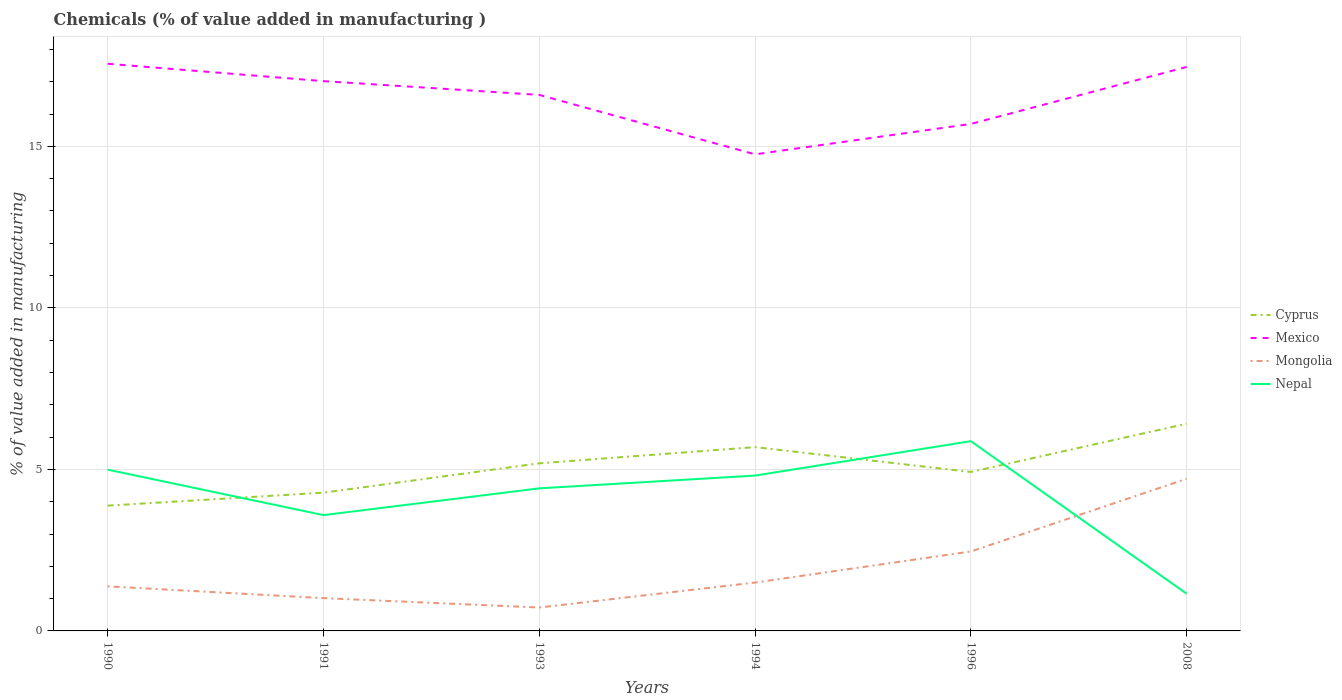How many different coloured lines are there?
Your response must be concise. 4. Does the line corresponding to Mongolia intersect with the line corresponding to Cyprus?
Provide a short and direct response. No. Across all years, what is the maximum value added in manufacturing chemicals in Nepal?
Ensure brevity in your answer.  1.15. What is the total value added in manufacturing chemicals in Mongolia in the graph?
Your response must be concise. -1.44. What is the difference between the highest and the second highest value added in manufacturing chemicals in Cyprus?
Offer a very short reply. 2.54. How many lines are there?
Offer a very short reply. 4. How many years are there in the graph?
Ensure brevity in your answer.  6. Are the values on the major ticks of Y-axis written in scientific E-notation?
Your answer should be very brief. No. Does the graph contain grids?
Your answer should be compact. Yes. How are the legend labels stacked?
Your answer should be very brief. Vertical. What is the title of the graph?
Offer a terse response. Chemicals (% of value added in manufacturing ). Does "Sao Tome and Principe" appear as one of the legend labels in the graph?
Provide a short and direct response. No. What is the label or title of the X-axis?
Make the answer very short. Years. What is the label or title of the Y-axis?
Offer a terse response. % of value added in manufacturing. What is the % of value added in manufacturing of Cyprus in 1990?
Ensure brevity in your answer.  3.88. What is the % of value added in manufacturing of Mexico in 1990?
Ensure brevity in your answer.  17.56. What is the % of value added in manufacturing of Mongolia in 1990?
Offer a terse response. 1.38. What is the % of value added in manufacturing of Nepal in 1990?
Ensure brevity in your answer.  4.99. What is the % of value added in manufacturing of Cyprus in 1991?
Offer a very short reply. 4.28. What is the % of value added in manufacturing of Mexico in 1991?
Give a very brief answer. 17.02. What is the % of value added in manufacturing in Mongolia in 1991?
Provide a succinct answer. 1.02. What is the % of value added in manufacturing of Nepal in 1991?
Your answer should be compact. 3.58. What is the % of value added in manufacturing of Cyprus in 1993?
Offer a terse response. 5.19. What is the % of value added in manufacturing of Mexico in 1993?
Provide a succinct answer. 16.59. What is the % of value added in manufacturing of Mongolia in 1993?
Ensure brevity in your answer.  0.72. What is the % of value added in manufacturing of Nepal in 1993?
Provide a succinct answer. 4.41. What is the % of value added in manufacturing of Cyprus in 1994?
Provide a short and direct response. 5.69. What is the % of value added in manufacturing of Mexico in 1994?
Provide a succinct answer. 14.75. What is the % of value added in manufacturing of Mongolia in 1994?
Ensure brevity in your answer.  1.5. What is the % of value added in manufacturing in Nepal in 1994?
Your response must be concise. 4.81. What is the % of value added in manufacturing in Cyprus in 1996?
Offer a very short reply. 4.92. What is the % of value added in manufacturing in Mexico in 1996?
Provide a succinct answer. 15.69. What is the % of value added in manufacturing of Mongolia in 1996?
Offer a terse response. 2.46. What is the % of value added in manufacturing in Nepal in 1996?
Provide a short and direct response. 5.87. What is the % of value added in manufacturing in Cyprus in 2008?
Your answer should be compact. 6.41. What is the % of value added in manufacturing in Mexico in 2008?
Your answer should be compact. 17.46. What is the % of value added in manufacturing of Mongolia in 2008?
Provide a short and direct response. 4.71. What is the % of value added in manufacturing in Nepal in 2008?
Keep it short and to the point. 1.15. Across all years, what is the maximum % of value added in manufacturing of Cyprus?
Offer a very short reply. 6.41. Across all years, what is the maximum % of value added in manufacturing in Mexico?
Keep it short and to the point. 17.56. Across all years, what is the maximum % of value added in manufacturing in Mongolia?
Offer a very short reply. 4.71. Across all years, what is the maximum % of value added in manufacturing of Nepal?
Ensure brevity in your answer.  5.87. Across all years, what is the minimum % of value added in manufacturing in Cyprus?
Ensure brevity in your answer.  3.88. Across all years, what is the minimum % of value added in manufacturing in Mexico?
Offer a very short reply. 14.75. Across all years, what is the minimum % of value added in manufacturing of Mongolia?
Ensure brevity in your answer.  0.72. Across all years, what is the minimum % of value added in manufacturing of Nepal?
Make the answer very short. 1.15. What is the total % of value added in manufacturing of Cyprus in the graph?
Your answer should be very brief. 30.37. What is the total % of value added in manufacturing of Mexico in the graph?
Your response must be concise. 99.07. What is the total % of value added in manufacturing in Mongolia in the graph?
Provide a succinct answer. 11.78. What is the total % of value added in manufacturing in Nepal in the graph?
Keep it short and to the point. 24.82. What is the difference between the % of value added in manufacturing in Cyprus in 1990 and that in 1991?
Offer a very short reply. -0.4. What is the difference between the % of value added in manufacturing in Mexico in 1990 and that in 1991?
Make the answer very short. 0.54. What is the difference between the % of value added in manufacturing in Mongolia in 1990 and that in 1991?
Make the answer very short. 0.36. What is the difference between the % of value added in manufacturing of Nepal in 1990 and that in 1991?
Keep it short and to the point. 1.41. What is the difference between the % of value added in manufacturing of Cyprus in 1990 and that in 1993?
Offer a terse response. -1.31. What is the difference between the % of value added in manufacturing of Mexico in 1990 and that in 1993?
Your answer should be very brief. 0.96. What is the difference between the % of value added in manufacturing in Mongolia in 1990 and that in 1993?
Ensure brevity in your answer.  0.66. What is the difference between the % of value added in manufacturing in Nepal in 1990 and that in 1993?
Give a very brief answer. 0.58. What is the difference between the % of value added in manufacturing of Cyprus in 1990 and that in 1994?
Your answer should be compact. -1.81. What is the difference between the % of value added in manufacturing of Mexico in 1990 and that in 1994?
Your answer should be very brief. 2.8. What is the difference between the % of value added in manufacturing in Mongolia in 1990 and that in 1994?
Offer a very short reply. -0.12. What is the difference between the % of value added in manufacturing in Nepal in 1990 and that in 1994?
Ensure brevity in your answer.  0.18. What is the difference between the % of value added in manufacturing in Cyprus in 1990 and that in 1996?
Your answer should be very brief. -1.04. What is the difference between the % of value added in manufacturing in Mexico in 1990 and that in 1996?
Keep it short and to the point. 1.86. What is the difference between the % of value added in manufacturing in Mongolia in 1990 and that in 1996?
Ensure brevity in your answer.  -1.08. What is the difference between the % of value added in manufacturing in Nepal in 1990 and that in 1996?
Keep it short and to the point. -0.88. What is the difference between the % of value added in manufacturing in Cyprus in 1990 and that in 2008?
Your answer should be compact. -2.54. What is the difference between the % of value added in manufacturing of Mexico in 1990 and that in 2008?
Your response must be concise. 0.1. What is the difference between the % of value added in manufacturing in Mongolia in 1990 and that in 2008?
Your answer should be compact. -3.33. What is the difference between the % of value added in manufacturing in Nepal in 1990 and that in 2008?
Your answer should be very brief. 3.84. What is the difference between the % of value added in manufacturing of Cyprus in 1991 and that in 1993?
Provide a short and direct response. -0.91. What is the difference between the % of value added in manufacturing of Mexico in 1991 and that in 1993?
Your response must be concise. 0.43. What is the difference between the % of value added in manufacturing of Mongolia in 1991 and that in 1993?
Make the answer very short. 0.29. What is the difference between the % of value added in manufacturing of Nepal in 1991 and that in 1993?
Offer a very short reply. -0.83. What is the difference between the % of value added in manufacturing in Cyprus in 1991 and that in 1994?
Keep it short and to the point. -1.41. What is the difference between the % of value added in manufacturing of Mexico in 1991 and that in 1994?
Offer a terse response. 2.27. What is the difference between the % of value added in manufacturing in Mongolia in 1991 and that in 1994?
Ensure brevity in your answer.  -0.48. What is the difference between the % of value added in manufacturing in Nepal in 1991 and that in 1994?
Offer a very short reply. -1.22. What is the difference between the % of value added in manufacturing of Cyprus in 1991 and that in 1996?
Your answer should be very brief. -0.64. What is the difference between the % of value added in manufacturing of Mexico in 1991 and that in 1996?
Provide a short and direct response. 1.32. What is the difference between the % of value added in manufacturing in Mongolia in 1991 and that in 1996?
Ensure brevity in your answer.  -1.44. What is the difference between the % of value added in manufacturing in Nepal in 1991 and that in 1996?
Make the answer very short. -2.29. What is the difference between the % of value added in manufacturing in Cyprus in 1991 and that in 2008?
Offer a terse response. -2.13. What is the difference between the % of value added in manufacturing in Mexico in 1991 and that in 2008?
Give a very brief answer. -0.44. What is the difference between the % of value added in manufacturing of Mongolia in 1991 and that in 2008?
Your answer should be compact. -3.69. What is the difference between the % of value added in manufacturing of Nepal in 1991 and that in 2008?
Offer a terse response. 2.43. What is the difference between the % of value added in manufacturing of Cyprus in 1993 and that in 1994?
Offer a very short reply. -0.5. What is the difference between the % of value added in manufacturing of Mexico in 1993 and that in 1994?
Your answer should be very brief. 1.84. What is the difference between the % of value added in manufacturing in Mongolia in 1993 and that in 1994?
Give a very brief answer. -0.77. What is the difference between the % of value added in manufacturing in Nepal in 1993 and that in 1994?
Give a very brief answer. -0.4. What is the difference between the % of value added in manufacturing of Cyprus in 1993 and that in 1996?
Ensure brevity in your answer.  0.27. What is the difference between the % of value added in manufacturing of Mexico in 1993 and that in 1996?
Provide a short and direct response. 0.9. What is the difference between the % of value added in manufacturing of Mongolia in 1993 and that in 1996?
Give a very brief answer. -1.73. What is the difference between the % of value added in manufacturing of Nepal in 1993 and that in 1996?
Keep it short and to the point. -1.46. What is the difference between the % of value added in manufacturing in Cyprus in 1993 and that in 2008?
Ensure brevity in your answer.  -1.23. What is the difference between the % of value added in manufacturing of Mexico in 1993 and that in 2008?
Provide a succinct answer. -0.87. What is the difference between the % of value added in manufacturing in Mongolia in 1993 and that in 2008?
Your answer should be very brief. -3.99. What is the difference between the % of value added in manufacturing in Nepal in 1993 and that in 2008?
Give a very brief answer. 3.26. What is the difference between the % of value added in manufacturing of Cyprus in 1994 and that in 1996?
Keep it short and to the point. 0.77. What is the difference between the % of value added in manufacturing in Mexico in 1994 and that in 1996?
Your response must be concise. -0.94. What is the difference between the % of value added in manufacturing in Mongolia in 1994 and that in 1996?
Keep it short and to the point. -0.96. What is the difference between the % of value added in manufacturing in Nepal in 1994 and that in 1996?
Keep it short and to the point. -1.07. What is the difference between the % of value added in manufacturing of Cyprus in 1994 and that in 2008?
Your response must be concise. -0.72. What is the difference between the % of value added in manufacturing in Mexico in 1994 and that in 2008?
Ensure brevity in your answer.  -2.71. What is the difference between the % of value added in manufacturing in Mongolia in 1994 and that in 2008?
Provide a short and direct response. -3.21. What is the difference between the % of value added in manufacturing in Nepal in 1994 and that in 2008?
Offer a very short reply. 3.66. What is the difference between the % of value added in manufacturing in Cyprus in 1996 and that in 2008?
Give a very brief answer. -1.49. What is the difference between the % of value added in manufacturing of Mexico in 1996 and that in 2008?
Provide a short and direct response. -1.76. What is the difference between the % of value added in manufacturing in Mongolia in 1996 and that in 2008?
Ensure brevity in your answer.  -2.25. What is the difference between the % of value added in manufacturing of Nepal in 1996 and that in 2008?
Provide a succinct answer. 4.72. What is the difference between the % of value added in manufacturing of Cyprus in 1990 and the % of value added in manufacturing of Mexico in 1991?
Give a very brief answer. -13.14. What is the difference between the % of value added in manufacturing in Cyprus in 1990 and the % of value added in manufacturing in Mongolia in 1991?
Your answer should be very brief. 2.86. What is the difference between the % of value added in manufacturing of Cyprus in 1990 and the % of value added in manufacturing of Nepal in 1991?
Your answer should be compact. 0.29. What is the difference between the % of value added in manufacturing in Mexico in 1990 and the % of value added in manufacturing in Mongolia in 1991?
Offer a terse response. 16.54. What is the difference between the % of value added in manufacturing of Mexico in 1990 and the % of value added in manufacturing of Nepal in 1991?
Provide a succinct answer. 13.97. What is the difference between the % of value added in manufacturing of Mongolia in 1990 and the % of value added in manufacturing of Nepal in 1991?
Provide a succinct answer. -2.21. What is the difference between the % of value added in manufacturing of Cyprus in 1990 and the % of value added in manufacturing of Mexico in 1993?
Provide a short and direct response. -12.71. What is the difference between the % of value added in manufacturing of Cyprus in 1990 and the % of value added in manufacturing of Mongolia in 1993?
Offer a terse response. 3.15. What is the difference between the % of value added in manufacturing in Cyprus in 1990 and the % of value added in manufacturing in Nepal in 1993?
Your response must be concise. -0.54. What is the difference between the % of value added in manufacturing of Mexico in 1990 and the % of value added in manufacturing of Mongolia in 1993?
Offer a terse response. 16.83. What is the difference between the % of value added in manufacturing of Mexico in 1990 and the % of value added in manufacturing of Nepal in 1993?
Ensure brevity in your answer.  13.14. What is the difference between the % of value added in manufacturing in Mongolia in 1990 and the % of value added in manufacturing in Nepal in 1993?
Provide a short and direct response. -3.03. What is the difference between the % of value added in manufacturing in Cyprus in 1990 and the % of value added in manufacturing in Mexico in 1994?
Your response must be concise. -10.87. What is the difference between the % of value added in manufacturing of Cyprus in 1990 and the % of value added in manufacturing of Mongolia in 1994?
Provide a short and direct response. 2.38. What is the difference between the % of value added in manufacturing of Cyprus in 1990 and the % of value added in manufacturing of Nepal in 1994?
Offer a very short reply. -0.93. What is the difference between the % of value added in manufacturing of Mexico in 1990 and the % of value added in manufacturing of Mongolia in 1994?
Offer a very short reply. 16.06. What is the difference between the % of value added in manufacturing of Mexico in 1990 and the % of value added in manufacturing of Nepal in 1994?
Keep it short and to the point. 12.75. What is the difference between the % of value added in manufacturing in Mongolia in 1990 and the % of value added in manufacturing in Nepal in 1994?
Your answer should be very brief. -3.43. What is the difference between the % of value added in manufacturing in Cyprus in 1990 and the % of value added in manufacturing in Mexico in 1996?
Your response must be concise. -11.82. What is the difference between the % of value added in manufacturing of Cyprus in 1990 and the % of value added in manufacturing of Mongolia in 1996?
Provide a succinct answer. 1.42. What is the difference between the % of value added in manufacturing in Cyprus in 1990 and the % of value added in manufacturing in Nepal in 1996?
Give a very brief answer. -2. What is the difference between the % of value added in manufacturing of Mexico in 1990 and the % of value added in manufacturing of Mongolia in 1996?
Make the answer very short. 15.1. What is the difference between the % of value added in manufacturing in Mexico in 1990 and the % of value added in manufacturing in Nepal in 1996?
Offer a terse response. 11.68. What is the difference between the % of value added in manufacturing in Mongolia in 1990 and the % of value added in manufacturing in Nepal in 1996?
Provide a succinct answer. -4.49. What is the difference between the % of value added in manufacturing of Cyprus in 1990 and the % of value added in manufacturing of Mexico in 2008?
Provide a short and direct response. -13.58. What is the difference between the % of value added in manufacturing of Cyprus in 1990 and the % of value added in manufacturing of Mongolia in 2008?
Your answer should be compact. -0.83. What is the difference between the % of value added in manufacturing in Cyprus in 1990 and the % of value added in manufacturing in Nepal in 2008?
Provide a succinct answer. 2.73. What is the difference between the % of value added in manufacturing of Mexico in 1990 and the % of value added in manufacturing of Mongolia in 2008?
Provide a succinct answer. 12.85. What is the difference between the % of value added in manufacturing of Mexico in 1990 and the % of value added in manufacturing of Nepal in 2008?
Keep it short and to the point. 16.4. What is the difference between the % of value added in manufacturing of Mongolia in 1990 and the % of value added in manufacturing of Nepal in 2008?
Keep it short and to the point. 0.23. What is the difference between the % of value added in manufacturing of Cyprus in 1991 and the % of value added in manufacturing of Mexico in 1993?
Keep it short and to the point. -12.31. What is the difference between the % of value added in manufacturing of Cyprus in 1991 and the % of value added in manufacturing of Mongolia in 1993?
Offer a terse response. 3.56. What is the difference between the % of value added in manufacturing in Cyprus in 1991 and the % of value added in manufacturing in Nepal in 1993?
Offer a terse response. -0.13. What is the difference between the % of value added in manufacturing of Mexico in 1991 and the % of value added in manufacturing of Mongolia in 1993?
Keep it short and to the point. 16.29. What is the difference between the % of value added in manufacturing of Mexico in 1991 and the % of value added in manufacturing of Nepal in 1993?
Provide a short and direct response. 12.61. What is the difference between the % of value added in manufacturing in Mongolia in 1991 and the % of value added in manufacturing in Nepal in 1993?
Keep it short and to the point. -3.4. What is the difference between the % of value added in manufacturing of Cyprus in 1991 and the % of value added in manufacturing of Mexico in 1994?
Your answer should be compact. -10.47. What is the difference between the % of value added in manufacturing of Cyprus in 1991 and the % of value added in manufacturing of Mongolia in 1994?
Keep it short and to the point. 2.78. What is the difference between the % of value added in manufacturing in Cyprus in 1991 and the % of value added in manufacturing in Nepal in 1994?
Offer a very short reply. -0.53. What is the difference between the % of value added in manufacturing of Mexico in 1991 and the % of value added in manufacturing of Mongolia in 1994?
Keep it short and to the point. 15.52. What is the difference between the % of value added in manufacturing of Mexico in 1991 and the % of value added in manufacturing of Nepal in 1994?
Make the answer very short. 12.21. What is the difference between the % of value added in manufacturing of Mongolia in 1991 and the % of value added in manufacturing of Nepal in 1994?
Provide a short and direct response. -3.79. What is the difference between the % of value added in manufacturing of Cyprus in 1991 and the % of value added in manufacturing of Mexico in 1996?
Provide a short and direct response. -11.41. What is the difference between the % of value added in manufacturing in Cyprus in 1991 and the % of value added in manufacturing in Mongolia in 1996?
Keep it short and to the point. 1.82. What is the difference between the % of value added in manufacturing in Cyprus in 1991 and the % of value added in manufacturing in Nepal in 1996?
Offer a very short reply. -1.59. What is the difference between the % of value added in manufacturing of Mexico in 1991 and the % of value added in manufacturing of Mongolia in 1996?
Offer a terse response. 14.56. What is the difference between the % of value added in manufacturing of Mexico in 1991 and the % of value added in manufacturing of Nepal in 1996?
Offer a very short reply. 11.14. What is the difference between the % of value added in manufacturing of Mongolia in 1991 and the % of value added in manufacturing of Nepal in 1996?
Your response must be concise. -4.86. What is the difference between the % of value added in manufacturing in Cyprus in 1991 and the % of value added in manufacturing in Mexico in 2008?
Ensure brevity in your answer.  -13.18. What is the difference between the % of value added in manufacturing of Cyprus in 1991 and the % of value added in manufacturing of Mongolia in 2008?
Provide a short and direct response. -0.43. What is the difference between the % of value added in manufacturing of Cyprus in 1991 and the % of value added in manufacturing of Nepal in 2008?
Ensure brevity in your answer.  3.13. What is the difference between the % of value added in manufacturing in Mexico in 1991 and the % of value added in manufacturing in Mongolia in 2008?
Provide a short and direct response. 12.31. What is the difference between the % of value added in manufacturing of Mexico in 1991 and the % of value added in manufacturing of Nepal in 2008?
Make the answer very short. 15.87. What is the difference between the % of value added in manufacturing of Mongolia in 1991 and the % of value added in manufacturing of Nepal in 2008?
Your answer should be compact. -0.14. What is the difference between the % of value added in manufacturing in Cyprus in 1993 and the % of value added in manufacturing in Mexico in 1994?
Make the answer very short. -9.56. What is the difference between the % of value added in manufacturing of Cyprus in 1993 and the % of value added in manufacturing of Mongolia in 1994?
Keep it short and to the point. 3.69. What is the difference between the % of value added in manufacturing in Cyprus in 1993 and the % of value added in manufacturing in Nepal in 1994?
Keep it short and to the point. 0.38. What is the difference between the % of value added in manufacturing in Mexico in 1993 and the % of value added in manufacturing in Mongolia in 1994?
Your response must be concise. 15.1. What is the difference between the % of value added in manufacturing of Mexico in 1993 and the % of value added in manufacturing of Nepal in 1994?
Your answer should be compact. 11.78. What is the difference between the % of value added in manufacturing of Mongolia in 1993 and the % of value added in manufacturing of Nepal in 1994?
Offer a terse response. -4.08. What is the difference between the % of value added in manufacturing of Cyprus in 1993 and the % of value added in manufacturing of Mexico in 1996?
Give a very brief answer. -10.51. What is the difference between the % of value added in manufacturing of Cyprus in 1993 and the % of value added in manufacturing of Mongolia in 1996?
Make the answer very short. 2.73. What is the difference between the % of value added in manufacturing of Cyprus in 1993 and the % of value added in manufacturing of Nepal in 1996?
Your response must be concise. -0.69. What is the difference between the % of value added in manufacturing of Mexico in 1993 and the % of value added in manufacturing of Mongolia in 1996?
Your response must be concise. 14.13. What is the difference between the % of value added in manufacturing in Mexico in 1993 and the % of value added in manufacturing in Nepal in 1996?
Your answer should be compact. 10.72. What is the difference between the % of value added in manufacturing of Mongolia in 1993 and the % of value added in manufacturing of Nepal in 1996?
Keep it short and to the point. -5.15. What is the difference between the % of value added in manufacturing in Cyprus in 1993 and the % of value added in manufacturing in Mexico in 2008?
Offer a terse response. -12.27. What is the difference between the % of value added in manufacturing of Cyprus in 1993 and the % of value added in manufacturing of Mongolia in 2008?
Offer a terse response. 0.48. What is the difference between the % of value added in manufacturing in Cyprus in 1993 and the % of value added in manufacturing in Nepal in 2008?
Ensure brevity in your answer.  4.04. What is the difference between the % of value added in manufacturing of Mexico in 1993 and the % of value added in manufacturing of Mongolia in 2008?
Give a very brief answer. 11.88. What is the difference between the % of value added in manufacturing of Mexico in 1993 and the % of value added in manufacturing of Nepal in 2008?
Keep it short and to the point. 15.44. What is the difference between the % of value added in manufacturing of Mongolia in 1993 and the % of value added in manufacturing of Nepal in 2008?
Give a very brief answer. -0.43. What is the difference between the % of value added in manufacturing of Cyprus in 1994 and the % of value added in manufacturing of Mexico in 1996?
Ensure brevity in your answer.  -10. What is the difference between the % of value added in manufacturing in Cyprus in 1994 and the % of value added in manufacturing in Mongolia in 1996?
Keep it short and to the point. 3.23. What is the difference between the % of value added in manufacturing in Cyprus in 1994 and the % of value added in manufacturing in Nepal in 1996?
Your answer should be very brief. -0.18. What is the difference between the % of value added in manufacturing of Mexico in 1994 and the % of value added in manufacturing of Mongolia in 1996?
Your answer should be compact. 12.29. What is the difference between the % of value added in manufacturing in Mexico in 1994 and the % of value added in manufacturing in Nepal in 1996?
Offer a terse response. 8.88. What is the difference between the % of value added in manufacturing of Mongolia in 1994 and the % of value added in manufacturing of Nepal in 1996?
Your response must be concise. -4.38. What is the difference between the % of value added in manufacturing of Cyprus in 1994 and the % of value added in manufacturing of Mexico in 2008?
Make the answer very short. -11.77. What is the difference between the % of value added in manufacturing in Cyprus in 1994 and the % of value added in manufacturing in Mongolia in 2008?
Give a very brief answer. 0.98. What is the difference between the % of value added in manufacturing of Cyprus in 1994 and the % of value added in manufacturing of Nepal in 2008?
Offer a terse response. 4.54. What is the difference between the % of value added in manufacturing in Mexico in 1994 and the % of value added in manufacturing in Mongolia in 2008?
Your answer should be compact. 10.04. What is the difference between the % of value added in manufacturing of Mexico in 1994 and the % of value added in manufacturing of Nepal in 2008?
Make the answer very short. 13.6. What is the difference between the % of value added in manufacturing in Mongolia in 1994 and the % of value added in manufacturing in Nepal in 2008?
Ensure brevity in your answer.  0.35. What is the difference between the % of value added in manufacturing in Cyprus in 1996 and the % of value added in manufacturing in Mexico in 2008?
Offer a terse response. -12.54. What is the difference between the % of value added in manufacturing of Cyprus in 1996 and the % of value added in manufacturing of Mongolia in 2008?
Keep it short and to the point. 0.21. What is the difference between the % of value added in manufacturing in Cyprus in 1996 and the % of value added in manufacturing in Nepal in 2008?
Provide a succinct answer. 3.77. What is the difference between the % of value added in manufacturing of Mexico in 1996 and the % of value added in manufacturing of Mongolia in 2008?
Provide a short and direct response. 10.98. What is the difference between the % of value added in manufacturing of Mexico in 1996 and the % of value added in manufacturing of Nepal in 2008?
Provide a short and direct response. 14.54. What is the difference between the % of value added in manufacturing in Mongolia in 1996 and the % of value added in manufacturing in Nepal in 2008?
Give a very brief answer. 1.31. What is the average % of value added in manufacturing in Cyprus per year?
Ensure brevity in your answer.  5.06. What is the average % of value added in manufacturing in Mexico per year?
Offer a terse response. 16.51. What is the average % of value added in manufacturing of Mongolia per year?
Give a very brief answer. 1.96. What is the average % of value added in manufacturing of Nepal per year?
Make the answer very short. 4.14. In the year 1990, what is the difference between the % of value added in manufacturing of Cyprus and % of value added in manufacturing of Mexico?
Offer a very short reply. -13.68. In the year 1990, what is the difference between the % of value added in manufacturing of Cyprus and % of value added in manufacturing of Mongolia?
Offer a terse response. 2.5. In the year 1990, what is the difference between the % of value added in manufacturing of Cyprus and % of value added in manufacturing of Nepal?
Provide a short and direct response. -1.11. In the year 1990, what is the difference between the % of value added in manufacturing in Mexico and % of value added in manufacturing in Mongolia?
Offer a terse response. 16.18. In the year 1990, what is the difference between the % of value added in manufacturing of Mexico and % of value added in manufacturing of Nepal?
Offer a very short reply. 12.56. In the year 1990, what is the difference between the % of value added in manufacturing of Mongolia and % of value added in manufacturing of Nepal?
Give a very brief answer. -3.61. In the year 1991, what is the difference between the % of value added in manufacturing in Cyprus and % of value added in manufacturing in Mexico?
Give a very brief answer. -12.74. In the year 1991, what is the difference between the % of value added in manufacturing in Cyprus and % of value added in manufacturing in Mongolia?
Your answer should be very brief. 3.26. In the year 1991, what is the difference between the % of value added in manufacturing of Cyprus and % of value added in manufacturing of Nepal?
Ensure brevity in your answer.  0.7. In the year 1991, what is the difference between the % of value added in manufacturing of Mexico and % of value added in manufacturing of Mongolia?
Offer a terse response. 16. In the year 1991, what is the difference between the % of value added in manufacturing in Mexico and % of value added in manufacturing in Nepal?
Ensure brevity in your answer.  13.43. In the year 1991, what is the difference between the % of value added in manufacturing in Mongolia and % of value added in manufacturing in Nepal?
Ensure brevity in your answer.  -2.57. In the year 1993, what is the difference between the % of value added in manufacturing in Cyprus and % of value added in manufacturing in Mexico?
Offer a very short reply. -11.41. In the year 1993, what is the difference between the % of value added in manufacturing in Cyprus and % of value added in manufacturing in Mongolia?
Offer a very short reply. 4.46. In the year 1993, what is the difference between the % of value added in manufacturing of Cyprus and % of value added in manufacturing of Nepal?
Ensure brevity in your answer.  0.77. In the year 1993, what is the difference between the % of value added in manufacturing of Mexico and % of value added in manufacturing of Mongolia?
Your response must be concise. 15.87. In the year 1993, what is the difference between the % of value added in manufacturing in Mexico and % of value added in manufacturing in Nepal?
Your answer should be compact. 12.18. In the year 1993, what is the difference between the % of value added in manufacturing in Mongolia and % of value added in manufacturing in Nepal?
Your answer should be compact. -3.69. In the year 1994, what is the difference between the % of value added in manufacturing of Cyprus and % of value added in manufacturing of Mexico?
Keep it short and to the point. -9.06. In the year 1994, what is the difference between the % of value added in manufacturing in Cyprus and % of value added in manufacturing in Mongolia?
Your answer should be very brief. 4.19. In the year 1994, what is the difference between the % of value added in manufacturing of Cyprus and % of value added in manufacturing of Nepal?
Your answer should be very brief. 0.88. In the year 1994, what is the difference between the % of value added in manufacturing in Mexico and % of value added in manufacturing in Mongolia?
Keep it short and to the point. 13.26. In the year 1994, what is the difference between the % of value added in manufacturing of Mexico and % of value added in manufacturing of Nepal?
Your response must be concise. 9.94. In the year 1994, what is the difference between the % of value added in manufacturing in Mongolia and % of value added in manufacturing in Nepal?
Provide a succinct answer. -3.31. In the year 1996, what is the difference between the % of value added in manufacturing in Cyprus and % of value added in manufacturing in Mexico?
Provide a succinct answer. -10.77. In the year 1996, what is the difference between the % of value added in manufacturing in Cyprus and % of value added in manufacturing in Mongolia?
Your response must be concise. 2.46. In the year 1996, what is the difference between the % of value added in manufacturing in Cyprus and % of value added in manufacturing in Nepal?
Make the answer very short. -0.95. In the year 1996, what is the difference between the % of value added in manufacturing in Mexico and % of value added in manufacturing in Mongolia?
Your answer should be compact. 13.23. In the year 1996, what is the difference between the % of value added in manufacturing in Mexico and % of value added in manufacturing in Nepal?
Offer a very short reply. 9.82. In the year 1996, what is the difference between the % of value added in manufacturing in Mongolia and % of value added in manufacturing in Nepal?
Offer a terse response. -3.42. In the year 2008, what is the difference between the % of value added in manufacturing in Cyprus and % of value added in manufacturing in Mexico?
Your answer should be very brief. -11.04. In the year 2008, what is the difference between the % of value added in manufacturing in Cyprus and % of value added in manufacturing in Mongolia?
Your answer should be very brief. 1.7. In the year 2008, what is the difference between the % of value added in manufacturing in Cyprus and % of value added in manufacturing in Nepal?
Give a very brief answer. 5.26. In the year 2008, what is the difference between the % of value added in manufacturing of Mexico and % of value added in manufacturing of Mongolia?
Make the answer very short. 12.75. In the year 2008, what is the difference between the % of value added in manufacturing in Mexico and % of value added in manufacturing in Nepal?
Your answer should be compact. 16.31. In the year 2008, what is the difference between the % of value added in manufacturing in Mongolia and % of value added in manufacturing in Nepal?
Your answer should be very brief. 3.56. What is the ratio of the % of value added in manufacturing in Cyprus in 1990 to that in 1991?
Give a very brief answer. 0.91. What is the ratio of the % of value added in manufacturing in Mexico in 1990 to that in 1991?
Your answer should be compact. 1.03. What is the ratio of the % of value added in manufacturing of Mongolia in 1990 to that in 1991?
Give a very brief answer. 1.36. What is the ratio of the % of value added in manufacturing in Nepal in 1990 to that in 1991?
Offer a very short reply. 1.39. What is the ratio of the % of value added in manufacturing in Cyprus in 1990 to that in 1993?
Provide a short and direct response. 0.75. What is the ratio of the % of value added in manufacturing in Mexico in 1990 to that in 1993?
Provide a succinct answer. 1.06. What is the ratio of the % of value added in manufacturing in Mongolia in 1990 to that in 1993?
Ensure brevity in your answer.  1.91. What is the ratio of the % of value added in manufacturing of Nepal in 1990 to that in 1993?
Offer a very short reply. 1.13. What is the ratio of the % of value added in manufacturing of Cyprus in 1990 to that in 1994?
Give a very brief answer. 0.68. What is the ratio of the % of value added in manufacturing of Mexico in 1990 to that in 1994?
Offer a very short reply. 1.19. What is the ratio of the % of value added in manufacturing of Mongolia in 1990 to that in 1994?
Offer a terse response. 0.92. What is the ratio of the % of value added in manufacturing of Nepal in 1990 to that in 1994?
Ensure brevity in your answer.  1.04. What is the ratio of the % of value added in manufacturing in Cyprus in 1990 to that in 1996?
Provide a succinct answer. 0.79. What is the ratio of the % of value added in manufacturing of Mexico in 1990 to that in 1996?
Offer a terse response. 1.12. What is the ratio of the % of value added in manufacturing in Mongolia in 1990 to that in 1996?
Give a very brief answer. 0.56. What is the ratio of the % of value added in manufacturing of Nepal in 1990 to that in 1996?
Keep it short and to the point. 0.85. What is the ratio of the % of value added in manufacturing in Cyprus in 1990 to that in 2008?
Ensure brevity in your answer.  0.6. What is the ratio of the % of value added in manufacturing in Mexico in 1990 to that in 2008?
Give a very brief answer. 1.01. What is the ratio of the % of value added in manufacturing in Mongolia in 1990 to that in 2008?
Your response must be concise. 0.29. What is the ratio of the % of value added in manufacturing of Nepal in 1990 to that in 2008?
Your answer should be very brief. 4.34. What is the ratio of the % of value added in manufacturing of Cyprus in 1991 to that in 1993?
Your answer should be compact. 0.82. What is the ratio of the % of value added in manufacturing in Mexico in 1991 to that in 1993?
Offer a very short reply. 1.03. What is the ratio of the % of value added in manufacturing of Mongolia in 1991 to that in 1993?
Keep it short and to the point. 1.4. What is the ratio of the % of value added in manufacturing in Nepal in 1991 to that in 1993?
Your answer should be very brief. 0.81. What is the ratio of the % of value added in manufacturing of Cyprus in 1991 to that in 1994?
Offer a very short reply. 0.75. What is the ratio of the % of value added in manufacturing of Mexico in 1991 to that in 1994?
Your answer should be compact. 1.15. What is the ratio of the % of value added in manufacturing of Mongolia in 1991 to that in 1994?
Give a very brief answer. 0.68. What is the ratio of the % of value added in manufacturing in Nepal in 1991 to that in 1994?
Ensure brevity in your answer.  0.75. What is the ratio of the % of value added in manufacturing in Cyprus in 1991 to that in 1996?
Keep it short and to the point. 0.87. What is the ratio of the % of value added in manufacturing in Mexico in 1991 to that in 1996?
Offer a terse response. 1.08. What is the ratio of the % of value added in manufacturing in Mongolia in 1991 to that in 1996?
Make the answer very short. 0.41. What is the ratio of the % of value added in manufacturing of Nepal in 1991 to that in 1996?
Provide a short and direct response. 0.61. What is the ratio of the % of value added in manufacturing of Cyprus in 1991 to that in 2008?
Keep it short and to the point. 0.67. What is the ratio of the % of value added in manufacturing of Mexico in 1991 to that in 2008?
Your answer should be compact. 0.97. What is the ratio of the % of value added in manufacturing of Mongolia in 1991 to that in 2008?
Your answer should be very brief. 0.22. What is the ratio of the % of value added in manufacturing of Nepal in 1991 to that in 2008?
Offer a very short reply. 3.11. What is the ratio of the % of value added in manufacturing of Cyprus in 1993 to that in 1994?
Offer a terse response. 0.91. What is the ratio of the % of value added in manufacturing of Mexico in 1993 to that in 1994?
Provide a short and direct response. 1.12. What is the ratio of the % of value added in manufacturing of Mongolia in 1993 to that in 1994?
Give a very brief answer. 0.48. What is the ratio of the % of value added in manufacturing in Nepal in 1993 to that in 1994?
Offer a terse response. 0.92. What is the ratio of the % of value added in manufacturing of Cyprus in 1993 to that in 1996?
Your response must be concise. 1.05. What is the ratio of the % of value added in manufacturing in Mexico in 1993 to that in 1996?
Ensure brevity in your answer.  1.06. What is the ratio of the % of value added in manufacturing in Mongolia in 1993 to that in 1996?
Ensure brevity in your answer.  0.29. What is the ratio of the % of value added in manufacturing of Nepal in 1993 to that in 1996?
Make the answer very short. 0.75. What is the ratio of the % of value added in manufacturing of Cyprus in 1993 to that in 2008?
Keep it short and to the point. 0.81. What is the ratio of the % of value added in manufacturing of Mexico in 1993 to that in 2008?
Your answer should be very brief. 0.95. What is the ratio of the % of value added in manufacturing in Mongolia in 1993 to that in 2008?
Provide a succinct answer. 0.15. What is the ratio of the % of value added in manufacturing in Nepal in 1993 to that in 2008?
Provide a short and direct response. 3.83. What is the ratio of the % of value added in manufacturing of Cyprus in 1994 to that in 1996?
Provide a short and direct response. 1.16. What is the ratio of the % of value added in manufacturing of Mexico in 1994 to that in 1996?
Offer a terse response. 0.94. What is the ratio of the % of value added in manufacturing in Mongolia in 1994 to that in 1996?
Offer a terse response. 0.61. What is the ratio of the % of value added in manufacturing of Nepal in 1994 to that in 1996?
Your answer should be compact. 0.82. What is the ratio of the % of value added in manufacturing of Cyprus in 1994 to that in 2008?
Ensure brevity in your answer.  0.89. What is the ratio of the % of value added in manufacturing of Mexico in 1994 to that in 2008?
Your answer should be very brief. 0.84. What is the ratio of the % of value added in manufacturing in Mongolia in 1994 to that in 2008?
Give a very brief answer. 0.32. What is the ratio of the % of value added in manufacturing in Nepal in 1994 to that in 2008?
Ensure brevity in your answer.  4.18. What is the ratio of the % of value added in manufacturing of Cyprus in 1996 to that in 2008?
Your response must be concise. 0.77. What is the ratio of the % of value added in manufacturing in Mexico in 1996 to that in 2008?
Ensure brevity in your answer.  0.9. What is the ratio of the % of value added in manufacturing of Mongolia in 1996 to that in 2008?
Make the answer very short. 0.52. What is the ratio of the % of value added in manufacturing in Nepal in 1996 to that in 2008?
Make the answer very short. 5.1. What is the difference between the highest and the second highest % of value added in manufacturing in Cyprus?
Offer a very short reply. 0.72. What is the difference between the highest and the second highest % of value added in manufacturing of Mexico?
Make the answer very short. 0.1. What is the difference between the highest and the second highest % of value added in manufacturing in Mongolia?
Keep it short and to the point. 2.25. What is the difference between the highest and the second highest % of value added in manufacturing in Nepal?
Make the answer very short. 0.88. What is the difference between the highest and the lowest % of value added in manufacturing of Cyprus?
Offer a terse response. 2.54. What is the difference between the highest and the lowest % of value added in manufacturing in Mexico?
Ensure brevity in your answer.  2.8. What is the difference between the highest and the lowest % of value added in manufacturing in Mongolia?
Your answer should be compact. 3.99. What is the difference between the highest and the lowest % of value added in manufacturing in Nepal?
Provide a short and direct response. 4.72. 